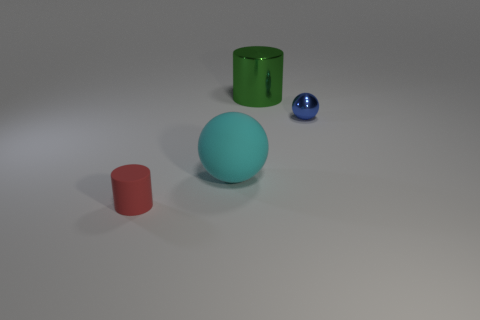Add 3 red things. How many objects exist? 7 Subtract all cyan balls. How many balls are left? 1 Add 3 blue things. How many blue things exist? 4 Subtract 0 purple cylinders. How many objects are left? 4 Subtract all yellow balls. Subtract all gray blocks. How many balls are left? 2 Subtract all tiny green blocks. Subtract all tiny red objects. How many objects are left? 3 Add 2 cyan balls. How many cyan balls are left? 3 